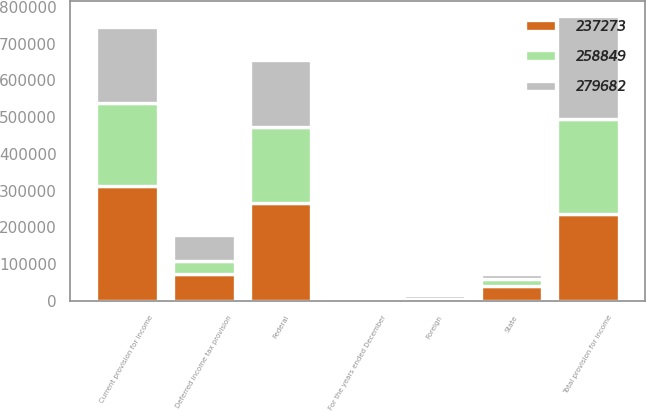Convert chart to OTSL. <chart><loc_0><loc_0><loc_500><loc_500><stacked_bar_chart><ecel><fcel>For the years ended December<fcel>Federal<fcel>State<fcel>Foreign<fcel>Current provision for income<fcel>Deferred income tax provision<fcel>Total provision for income<nl><fcel>279682<fcel>2005<fcel>184271<fcel>12326<fcel>12047<fcel>208644<fcel>71038<fcel>279682<nl><fcel>237273<fcel>2004<fcel>267645<fcel>39835<fcel>4363<fcel>311843<fcel>74570<fcel>237273<nl><fcel>258849<fcel>2003<fcel>204602<fcel>21318<fcel>571<fcel>225349<fcel>33500<fcel>258849<nl></chart> 